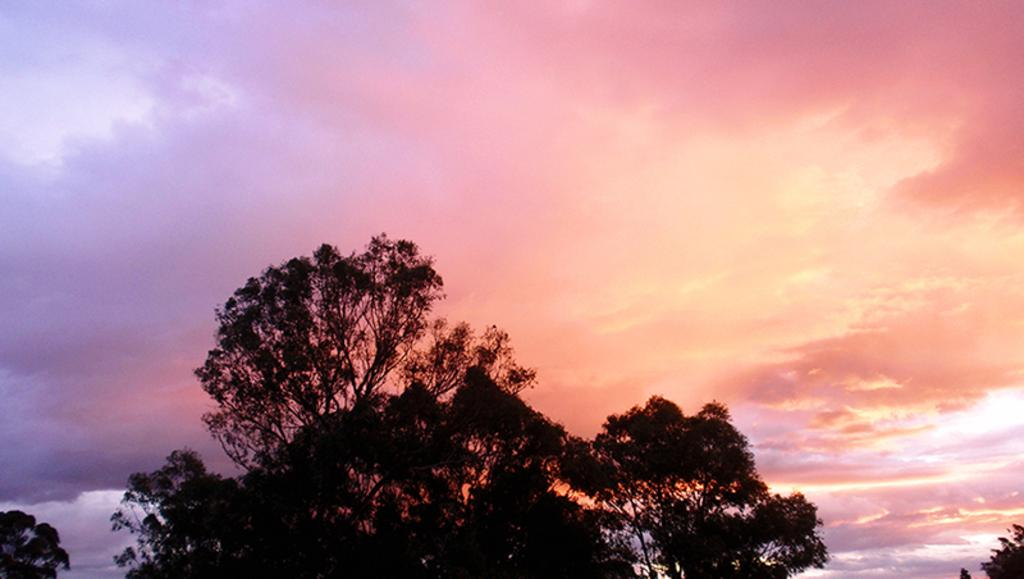What type of vegetation is at the bottom of the image? There are trees at the bottom of the image. What is visible at the top of the image? The sky is visible at the top of the image. What can be seen in the sky in the image? Clouds are present in the sky. What type of operation is being performed on the scissors in the image? There are no scissors present in the image, so no operation is being performed on them. What activity is taking place in the image involving the trees? There is no specific activity involving the trees mentioned in the image; they are simply present at the bottom of the image. 